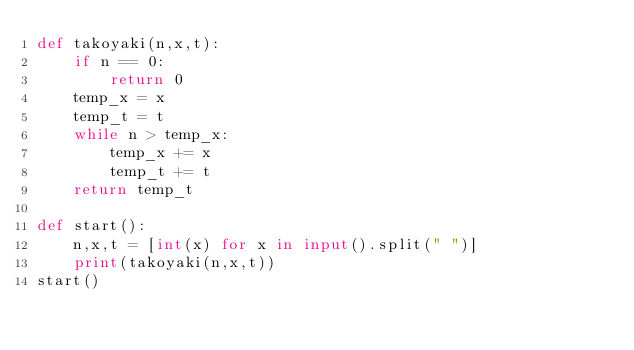<code> <loc_0><loc_0><loc_500><loc_500><_Python_>def takoyaki(n,x,t):
    if n == 0:
        return 0
    temp_x = x
    temp_t = t
    while n > temp_x:
        temp_x += x
        temp_t += t
    return temp_t

def start():
    n,x,t = [int(x) for x in input().split(" ")]
    print(takoyaki(n,x,t))
start()</code> 